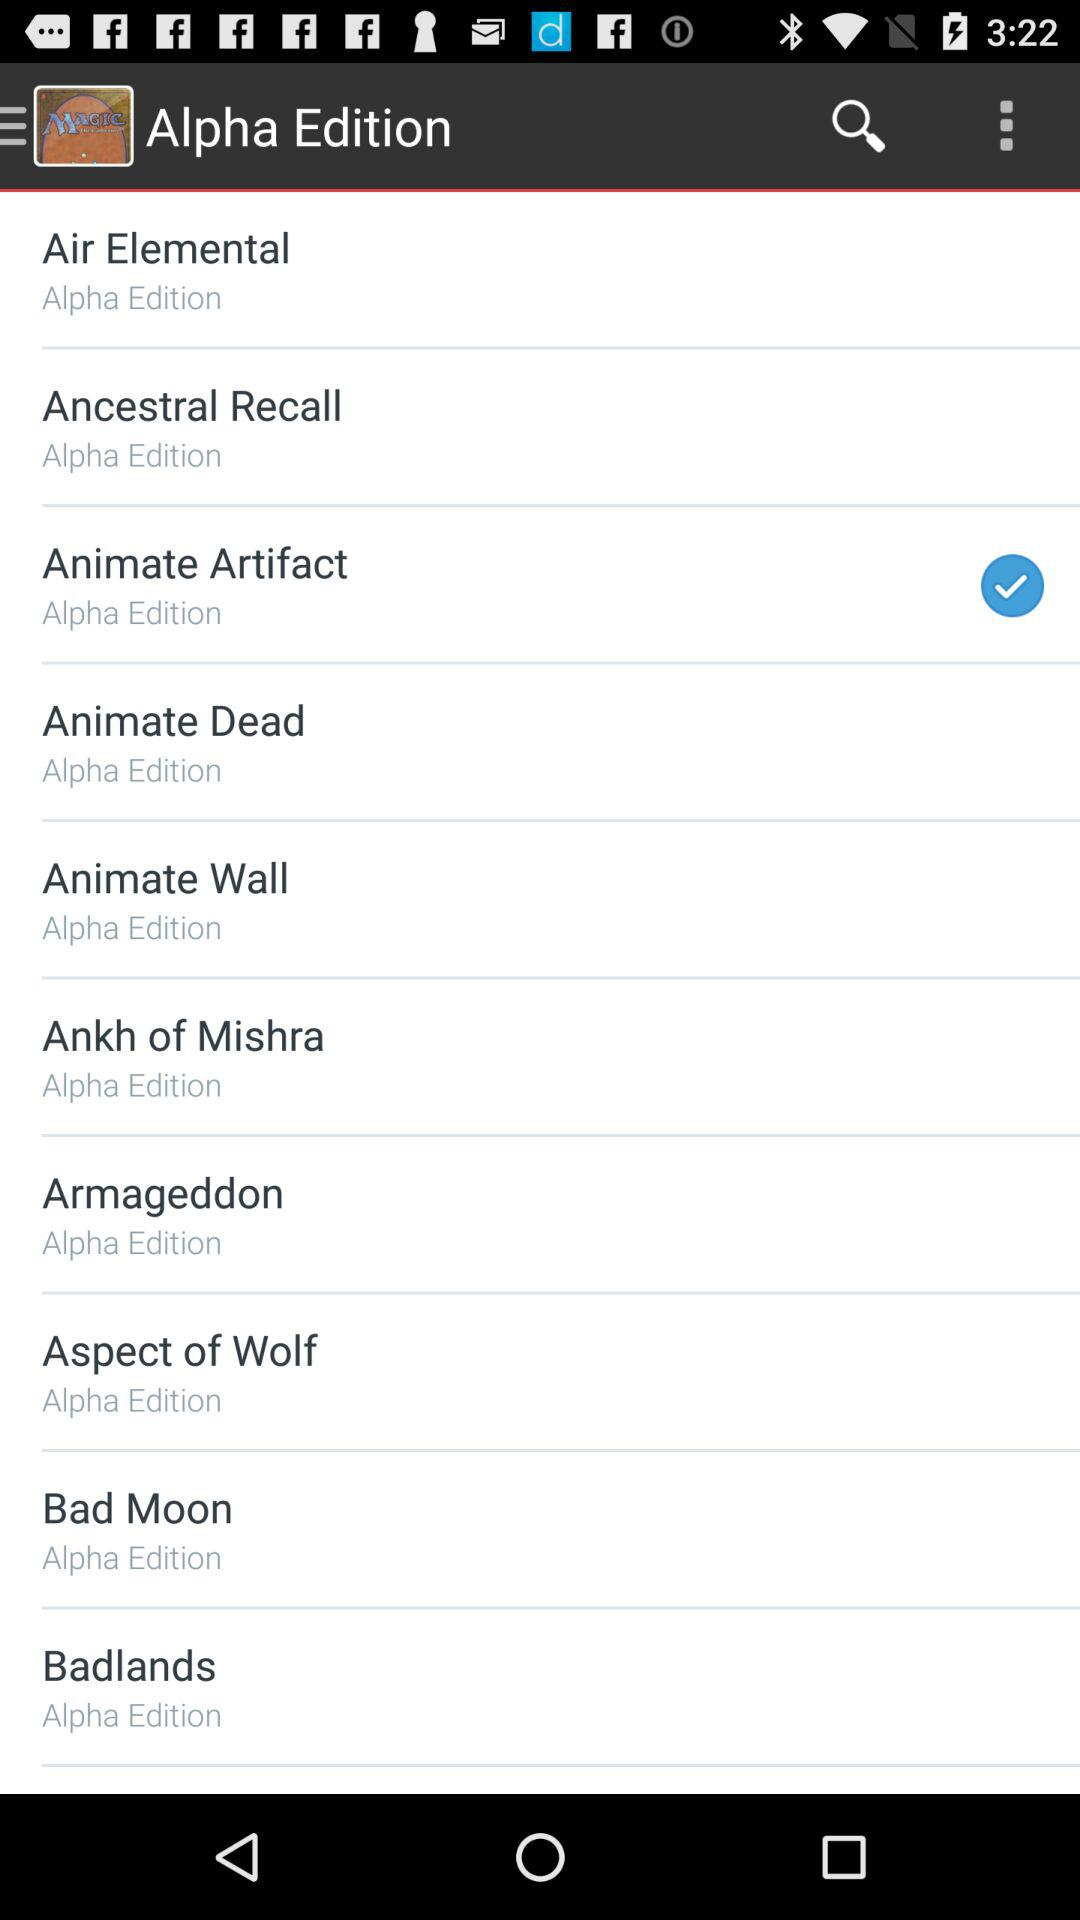Which option is selected? The selected option is "Animate Artifact". 